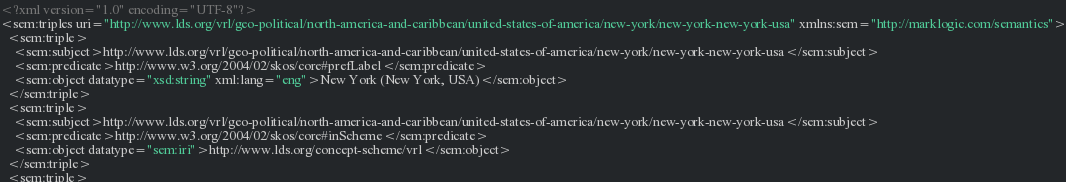<code> <loc_0><loc_0><loc_500><loc_500><_XML_><?xml version="1.0" encoding="UTF-8"?>
<sem:triples uri="http://www.lds.org/vrl/geo-political/north-america-and-caribbean/united-states-of-america/new-york/new-york-new-york-usa" xmlns:sem="http://marklogic.com/semantics">
  <sem:triple>
    <sem:subject>http://www.lds.org/vrl/geo-political/north-america-and-caribbean/united-states-of-america/new-york/new-york-new-york-usa</sem:subject>
    <sem:predicate>http://www.w3.org/2004/02/skos/core#prefLabel</sem:predicate>
    <sem:object datatype="xsd:string" xml:lang="eng">New York (New York, USA)</sem:object>
  </sem:triple>
  <sem:triple>
    <sem:subject>http://www.lds.org/vrl/geo-political/north-america-and-caribbean/united-states-of-america/new-york/new-york-new-york-usa</sem:subject>
    <sem:predicate>http://www.w3.org/2004/02/skos/core#inScheme</sem:predicate>
    <sem:object datatype="sem:iri">http://www.lds.org/concept-scheme/vrl</sem:object>
  </sem:triple>
  <sem:triple></code> 